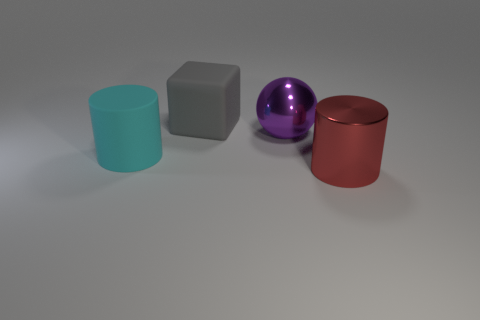There is a cylinder right of the large gray matte thing; what is it made of?
Your response must be concise. Metal. Is the number of large cyan shiny objects greater than the number of large balls?
Make the answer very short. No. There is a matte thing right of the large cyan rubber thing; does it have the same shape as the purple metallic object?
Offer a terse response. No. How many things are both to the left of the purple shiny object and behind the rubber cylinder?
Make the answer very short. 1. How many red shiny things have the same shape as the large cyan matte object?
Keep it short and to the point. 1. What is the color of the large rubber object that is behind the shiny thing that is behind the large red cylinder?
Your response must be concise. Gray. Does the cyan rubber object have the same shape as the metal object behind the big red shiny thing?
Offer a very short reply. No. There is a object that is behind the shiny thing that is behind the large red metallic thing that is in front of the large sphere; what is its material?
Offer a very short reply. Rubber. Is there a shiny block that has the same size as the red metallic thing?
Make the answer very short. No. There is a red cylinder that is made of the same material as the purple object; what is its size?
Offer a very short reply. Large. 